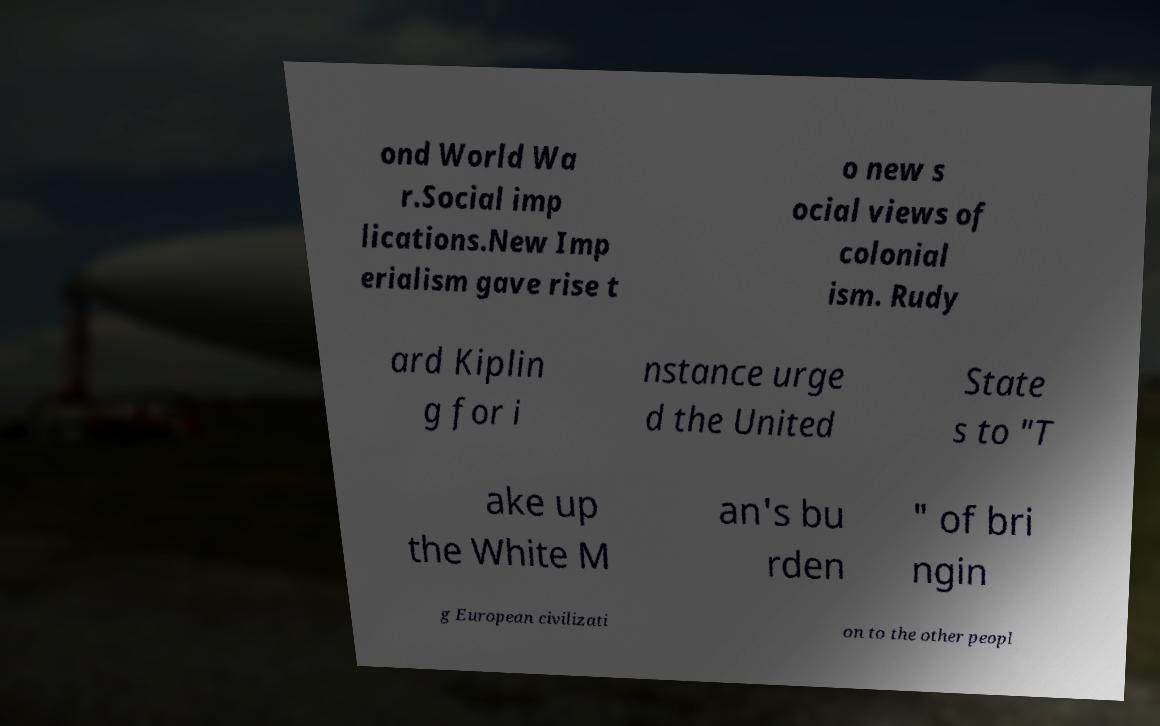Can you read and provide the text displayed in the image?This photo seems to have some interesting text. Can you extract and type it out for me? ond World Wa r.Social imp lications.New Imp erialism gave rise t o new s ocial views of colonial ism. Rudy ard Kiplin g for i nstance urge d the United State s to "T ake up the White M an's bu rden " of bri ngin g European civilizati on to the other peopl 